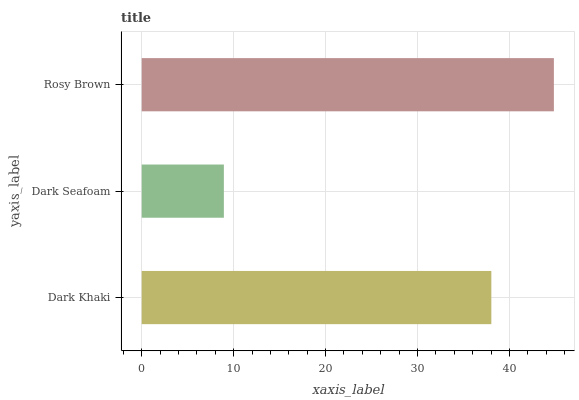Is Dark Seafoam the minimum?
Answer yes or no. Yes. Is Rosy Brown the maximum?
Answer yes or no. Yes. Is Rosy Brown the minimum?
Answer yes or no. No. Is Dark Seafoam the maximum?
Answer yes or no. No. Is Rosy Brown greater than Dark Seafoam?
Answer yes or no. Yes. Is Dark Seafoam less than Rosy Brown?
Answer yes or no. Yes. Is Dark Seafoam greater than Rosy Brown?
Answer yes or no. No. Is Rosy Brown less than Dark Seafoam?
Answer yes or no. No. Is Dark Khaki the high median?
Answer yes or no. Yes. Is Dark Khaki the low median?
Answer yes or no. Yes. Is Rosy Brown the high median?
Answer yes or no. No. Is Rosy Brown the low median?
Answer yes or no. No. 